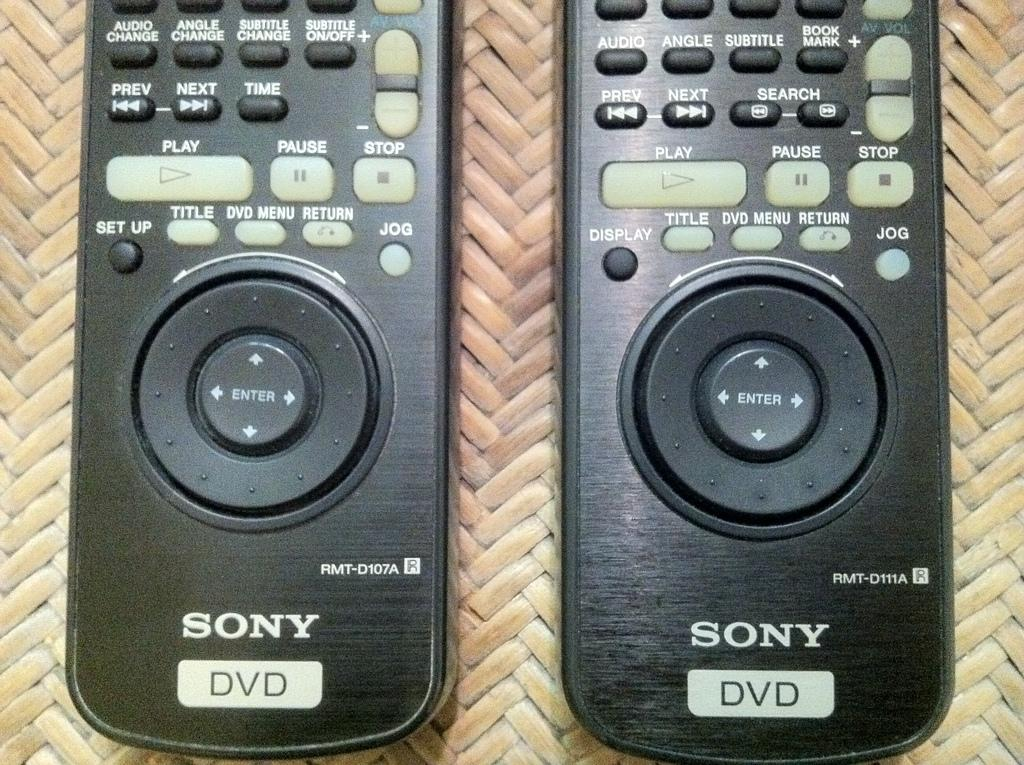Provide a one-sentence caption for the provided image. Two Sony black DVD remotes next to one another. 